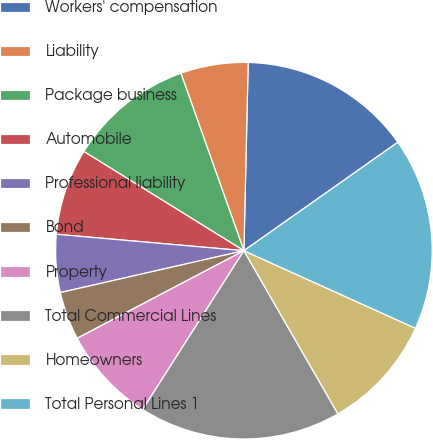<chart> <loc_0><loc_0><loc_500><loc_500><pie_chart><fcel>Workers' compensation<fcel>Liability<fcel>Package business<fcel>Automobile<fcel>Professional liability<fcel>Bond<fcel>Property<fcel>Total Commercial Lines<fcel>Homeowners<fcel>Total Personal Lines 1<nl><fcel>14.87%<fcel>5.79%<fcel>10.74%<fcel>7.44%<fcel>4.96%<fcel>4.13%<fcel>8.27%<fcel>17.35%<fcel>9.92%<fcel>16.53%<nl></chart> 